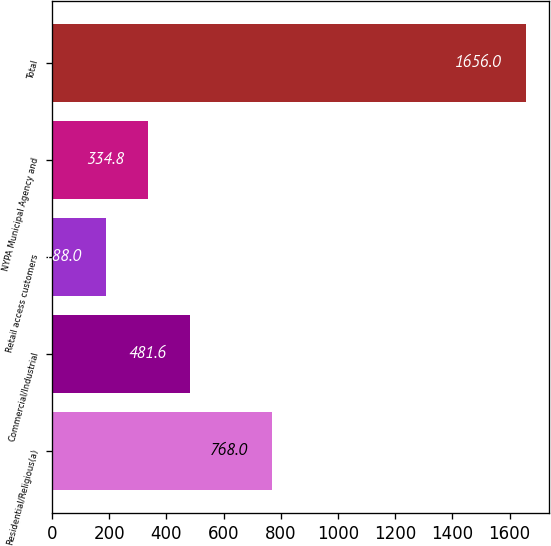Convert chart to OTSL. <chart><loc_0><loc_0><loc_500><loc_500><bar_chart><fcel>Residential/Religious(a)<fcel>Commercial/Industrial<fcel>Retail access customers<fcel>NYPA Municipal Agency and<fcel>Total<nl><fcel>768<fcel>481.6<fcel>188<fcel>334.8<fcel>1656<nl></chart> 